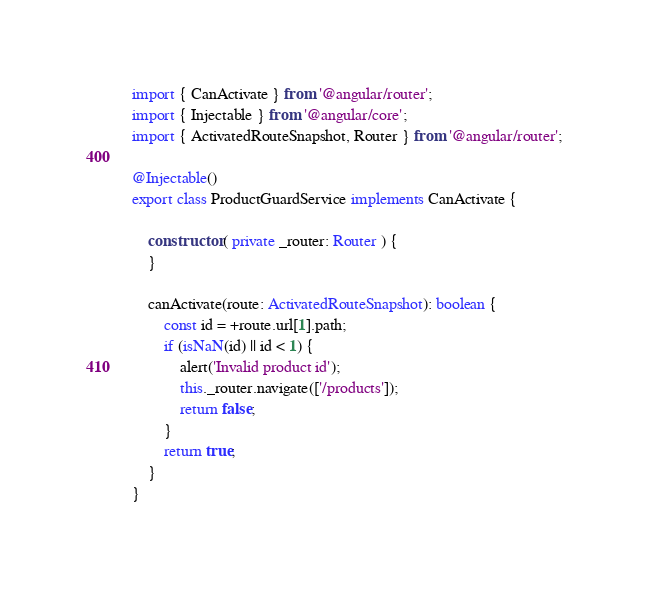Convert code to text. <code><loc_0><loc_0><loc_500><loc_500><_TypeScript_>import { CanActivate } from '@angular/router';
import { Injectable } from '@angular/core';
import { ActivatedRouteSnapshot, Router } from '@angular/router';

@Injectable()
export class ProductGuardService implements CanActivate {

    constructor ( private _router: Router ) {
    }

    canActivate(route: ActivatedRouteSnapshot): boolean {
        const id = +route.url[1].path;
        if (isNaN(id) || id < 1) {
            alert('Invalid product id');
            this._router.navigate(['/products']);
            return false;
        }
        return true;
    }
}
</code> 